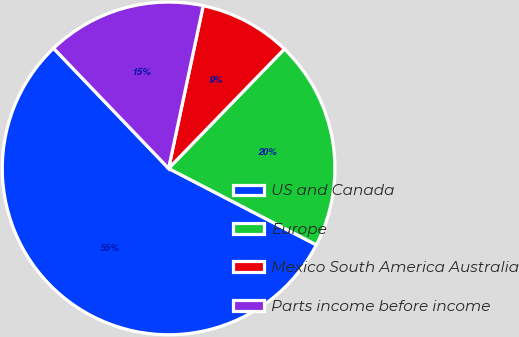Convert chart to OTSL. <chart><loc_0><loc_0><loc_500><loc_500><pie_chart><fcel>US and Canada<fcel>Europe<fcel>Mexico South America Australia<fcel>Parts income before income<nl><fcel>55.25%<fcel>20.35%<fcel>8.92%<fcel>15.49%<nl></chart> 